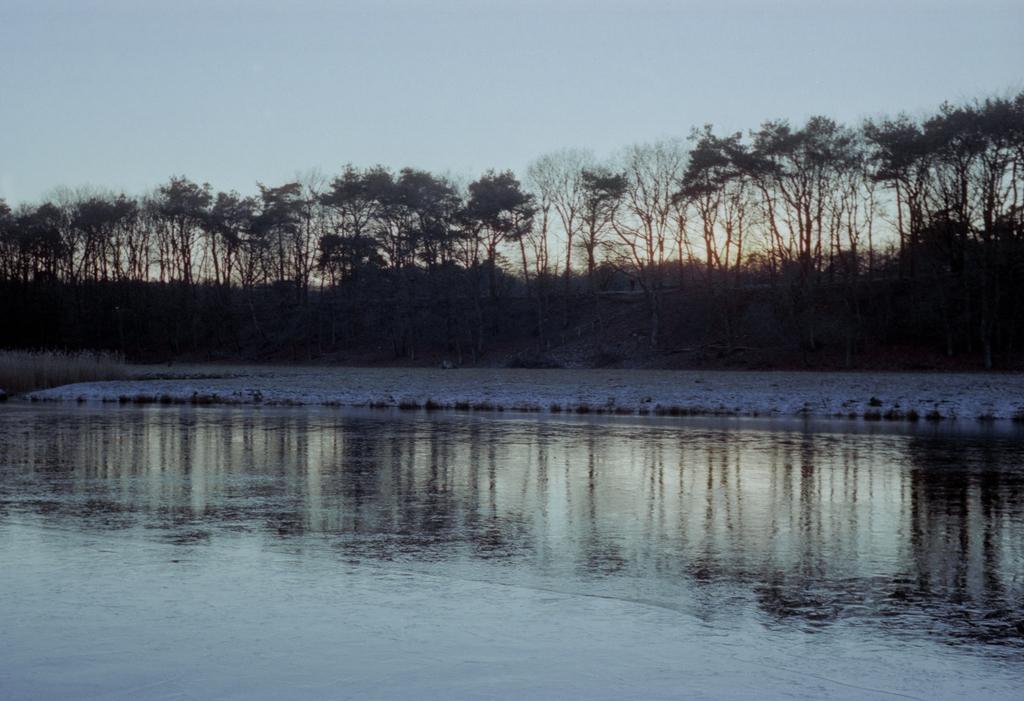Please provide a concise description of this image. In this picture I can see the water in front and in the background I can see number of trees and the clear sky. 